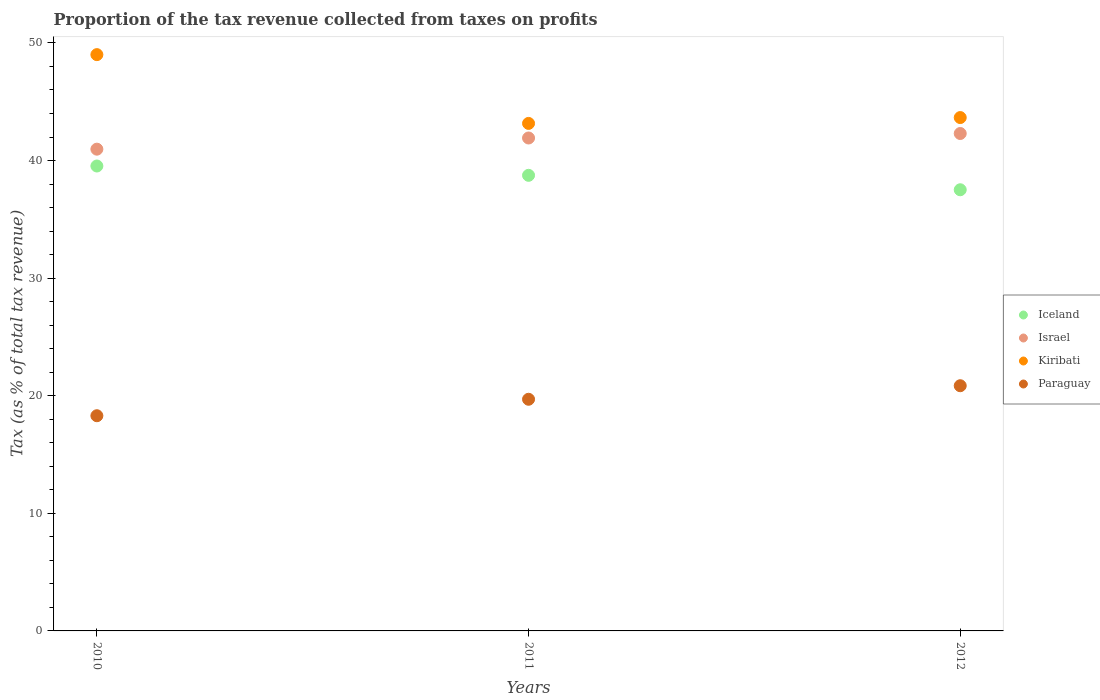How many different coloured dotlines are there?
Your answer should be compact. 4. Is the number of dotlines equal to the number of legend labels?
Give a very brief answer. Yes. What is the proportion of the tax revenue collected in Paraguay in 2011?
Keep it short and to the point. 19.7. Across all years, what is the maximum proportion of the tax revenue collected in Paraguay?
Provide a short and direct response. 20.85. Across all years, what is the minimum proportion of the tax revenue collected in Israel?
Keep it short and to the point. 40.97. In which year was the proportion of the tax revenue collected in Paraguay maximum?
Your response must be concise. 2012. In which year was the proportion of the tax revenue collected in Israel minimum?
Offer a very short reply. 2010. What is the total proportion of the tax revenue collected in Iceland in the graph?
Your response must be concise. 115.79. What is the difference between the proportion of the tax revenue collected in Paraguay in 2010 and that in 2011?
Keep it short and to the point. -1.4. What is the difference between the proportion of the tax revenue collected in Paraguay in 2011 and the proportion of the tax revenue collected in Israel in 2010?
Provide a succinct answer. -21.27. What is the average proportion of the tax revenue collected in Iceland per year?
Make the answer very short. 38.6. In the year 2010, what is the difference between the proportion of the tax revenue collected in Kiribati and proportion of the tax revenue collected in Paraguay?
Offer a terse response. 30.71. What is the ratio of the proportion of the tax revenue collected in Kiribati in 2010 to that in 2011?
Provide a short and direct response. 1.14. Is the proportion of the tax revenue collected in Israel in 2010 less than that in 2012?
Your response must be concise. Yes. Is the difference between the proportion of the tax revenue collected in Kiribati in 2010 and 2012 greater than the difference between the proportion of the tax revenue collected in Paraguay in 2010 and 2012?
Offer a terse response. Yes. What is the difference between the highest and the second highest proportion of the tax revenue collected in Paraguay?
Your answer should be very brief. 1.15. What is the difference between the highest and the lowest proportion of the tax revenue collected in Israel?
Ensure brevity in your answer.  1.33. Is the proportion of the tax revenue collected in Israel strictly greater than the proportion of the tax revenue collected in Kiribati over the years?
Provide a short and direct response. No. How many dotlines are there?
Offer a terse response. 4. How many years are there in the graph?
Give a very brief answer. 3. What is the difference between two consecutive major ticks on the Y-axis?
Offer a very short reply. 10. Are the values on the major ticks of Y-axis written in scientific E-notation?
Your answer should be very brief. No. Does the graph contain any zero values?
Your answer should be very brief. No. Where does the legend appear in the graph?
Offer a terse response. Center right. What is the title of the graph?
Ensure brevity in your answer.  Proportion of the tax revenue collected from taxes on profits. Does "Lao PDR" appear as one of the legend labels in the graph?
Give a very brief answer. No. What is the label or title of the Y-axis?
Provide a succinct answer. Tax (as % of total tax revenue). What is the Tax (as % of total tax revenue) of Iceland in 2010?
Ensure brevity in your answer.  39.53. What is the Tax (as % of total tax revenue) of Israel in 2010?
Offer a very short reply. 40.97. What is the Tax (as % of total tax revenue) in Kiribati in 2010?
Make the answer very short. 49. What is the Tax (as % of total tax revenue) in Paraguay in 2010?
Your answer should be compact. 18.3. What is the Tax (as % of total tax revenue) in Iceland in 2011?
Ensure brevity in your answer.  38.74. What is the Tax (as % of total tax revenue) of Israel in 2011?
Make the answer very short. 41.92. What is the Tax (as % of total tax revenue) of Kiribati in 2011?
Offer a very short reply. 43.16. What is the Tax (as % of total tax revenue) in Paraguay in 2011?
Provide a succinct answer. 19.7. What is the Tax (as % of total tax revenue) of Iceland in 2012?
Provide a short and direct response. 37.51. What is the Tax (as % of total tax revenue) of Israel in 2012?
Make the answer very short. 42.3. What is the Tax (as % of total tax revenue) of Kiribati in 2012?
Give a very brief answer. 43.65. What is the Tax (as % of total tax revenue) of Paraguay in 2012?
Your response must be concise. 20.85. Across all years, what is the maximum Tax (as % of total tax revenue) in Iceland?
Give a very brief answer. 39.53. Across all years, what is the maximum Tax (as % of total tax revenue) of Israel?
Make the answer very short. 42.3. Across all years, what is the maximum Tax (as % of total tax revenue) in Kiribati?
Ensure brevity in your answer.  49. Across all years, what is the maximum Tax (as % of total tax revenue) in Paraguay?
Offer a very short reply. 20.85. Across all years, what is the minimum Tax (as % of total tax revenue) in Iceland?
Your answer should be compact. 37.51. Across all years, what is the minimum Tax (as % of total tax revenue) of Israel?
Give a very brief answer. 40.97. Across all years, what is the minimum Tax (as % of total tax revenue) in Kiribati?
Ensure brevity in your answer.  43.16. Across all years, what is the minimum Tax (as % of total tax revenue) in Paraguay?
Ensure brevity in your answer.  18.3. What is the total Tax (as % of total tax revenue) in Iceland in the graph?
Your answer should be compact. 115.79. What is the total Tax (as % of total tax revenue) of Israel in the graph?
Your response must be concise. 125.18. What is the total Tax (as % of total tax revenue) of Kiribati in the graph?
Your response must be concise. 135.81. What is the total Tax (as % of total tax revenue) of Paraguay in the graph?
Keep it short and to the point. 58.85. What is the difference between the Tax (as % of total tax revenue) of Iceland in 2010 and that in 2011?
Provide a short and direct response. 0.79. What is the difference between the Tax (as % of total tax revenue) in Israel in 2010 and that in 2011?
Give a very brief answer. -0.95. What is the difference between the Tax (as % of total tax revenue) in Kiribati in 2010 and that in 2011?
Your answer should be very brief. 5.85. What is the difference between the Tax (as % of total tax revenue) in Paraguay in 2010 and that in 2011?
Keep it short and to the point. -1.4. What is the difference between the Tax (as % of total tax revenue) of Iceland in 2010 and that in 2012?
Offer a terse response. 2.02. What is the difference between the Tax (as % of total tax revenue) of Israel in 2010 and that in 2012?
Make the answer very short. -1.33. What is the difference between the Tax (as % of total tax revenue) of Kiribati in 2010 and that in 2012?
Provide a short and direct response. 5.35. What is the difference between the Tax (as % of total tax revenue) of Paraguay in 2010 and that in 2012?
Your answer should be very brief. -2.55. What is the difference between the Tax (as % of total tax revenue) in Iceland in 2011 and that in 2012?
Your answer should be compact. 1.23. What is the difference between the Tax (as % of total tax revenue) in Israel in 2011 and that in 2012?
Provide a short and direct response. -0.38. What is the difference between the Tax (as % of total tax revenue) of Kiribati in 2011 and that in 2012?
Your answer should be compact. -0.5. What is the difference between the Tax (as % of total tax revenue) in Paraguay in 2011 and that in 2012?
Offer a very short reply. -1.15. What is the difference between the Tax (as % of total tax revenue) in Iceland in 2010 and the Tax (as % of total tax revenue) in Israel in 2011?
Your response must be concise. -2.38. What is the difference between the Tax (as % of total tax revenue) of Iceland in 2010 and the Tax (as % of total tax revenue) of Kiribati in 2011?
Give a very brief answer. -3.62. What is the difference between the Tax (as % of total tax revenue) of Iceland in 2010 and the Tax (as % of total tax revenue) of Paraguay in 2011?
Offer a terse response. 19.84. What is the difference between the Tax (as % of total tax revenue) of Israel in 2010 and the Tax (as % of total tax revenue) of Kiribati in 2011?
Your answer should be compact. -2.19. What is the difference between the Tax (as % of total tax revenue) of Israel in 2010 and the Tax (as % of total tax revenue) of Paraguay in 2011?
Your response must be concise. 21.27. What is the difference between the Tax (as % of total tax revenue) in Kiribati in 2010 and the Tax (as % of total tax revenue) in Paraguay in 2011?
Your answer should be compact. 29.31. What is the difference between the Tax (as % of total tax revenue) of Iceland in 2010 and the Tax (as % of total tax revenue) of Israel in 2012?
Offer a very short reply. -2.76. What is the difference between the Tax (as % of total tax revenue) of Iceland in 2010 and the Tax (as % of total tax revenue) of Kiribati in 2012?
Keep it short and to the point. -4.12. What is the difference between the Tax (as % of total tax revenue) in Iceland in 2010 and the Tax (as % of total tax revenue) in Paraguay in 2012?
Offer a very short reply. 18.68. What is the difference between the Tax (as % of total tax revenue) of Israel in 2010 and the Tax (as % of total tax revenue) of Kiribati in 2012?
Your answer should be very brief. -2.69. What is the difference between the Tax (as % of total tax revenue) in Israel in 2010 and the Tax (as % of total tax revenue) in Paraguay in 2012?
Make the answer very short. 20.12. What is the difference between the Tax (as % of total tax revenue) in Kiribati in 2010 and the Tax (as % of total tax revenue) in Paraguay in 2012?
Make the answer very short. 28.15. What is the difference between the Tax (as % of total tax revenue) in Iceland in 2011 and the Tax (as % of total tax revenue) in Israel in 2012?
Give a very brief answer. -3.56. What is the difference between the Tax (as % of total tax revenue) of Iceland in 2011 and the Tax (as % of total tax revenue) of Kiribati in 2012?
Give a very brief answer. -4.91. What is the difference between the Tax (as % of total tax revenue) in Iceland in 2011 and the Tax (as % of total tax revenue) in Paraguay in 2012?
Provide a succinct answer. 17.89. What is the difference between the Tax (as % of total tax revenue) of Israel in 2011 and the Tax (as % of total tax revenue) of Kiribati in 2012?
Keep it short and to the point. -1.74. What is the difference between the Tax (as % of total tax revenue) in Israel in 2011 and the Tax (as % of total tax revenue) in Paraguay in 2012?
Provide a succinct answer. 21.07. What is the difference between the Tax (as % of total tax revenue) in Kiribati in 2011 and the Tax (as % of total tax revenue) in Paraguay in 2012?
Your answer should be compact. 22.31. What is the average Tax (as % of total tax revenue) of Iceland per year?
Provide a succinct answer. 38.6. What is the average Tax (as % of total tax revenue) of Israel per year?
Your answer should be compact. 41.73. What is the average Tax (as % of total tax revenue) of Kiribati per year?
Ensure brevity in your answer.  45.27. What is the average Tax (as % of total tax revenue) in Paraguay per year?
Ensure brevity in your answer.  19.62. In the year 2010, what is the difference between the Tax (as % of total tax revenue) of Iceland and Tax (as % of total tax revenue) of Israel?
Offer a terse response. -1.43. In the year 2010, what is the difference between the Tax (as % of total tax revenue) in Iceland and Tax (as % of total tax revenue) in Kiribati?
Your answer should be very brief. -9.47. In the year 2010, what is the difference between the Tax (as % of total tax revenue) in Iceland and Tax (as % of total tax revenue) in Paraguay?
Offer a terse response. 21.24. In the year 2010, what is the difference between the Tax (as % of total tax revenue) in Israel and Tax (as % of total tax revenue) in Kiribati?
Ensure brevity in your answer.  -8.04. In the year 2010, what is the difference between the Tax (as % of total tax revenue) of Israel and Tax (as % of total tax revenue) of Paraguay?
Keep it short and to the point. 22.67. In the year 2010, what is the difference between the Tax (as % of total tax revenue) in Kiribati and Tax (as % of total tax revenue) in Paraguay?
Provide a short and direct response. 30.71. In the year 2011, what is the difference between the Tax (as % of total tax revenue) in Iceland and Tax (as % of total tax revenue) in Israel?
Provide a short and direct response. -3.17. In the year 2011, what is the difference between the Tax (as % of total tax revenue) of Iceland and Tax (as % of total tax revenue) of Kiribati?
Ensure brevity in your answer.  -4.41. In the year 2011, what is the difference between the Tax (as % of total tax revenue) in Iceland and Tax (as % of total tax revenue) in Paraguay?
Your response must be concise. 19.04. In the year 2011, what is the difference between the Tax (as % of total tax revenue) of Israel and Tax (as % of total tax revenue) of Kiribati?
Offer a very short reply. -1.24. In the year 2011, what is the difference between the Tax (as % of total tax revenue) of Israel and Tax (as % of total tax revenue) of Paraguay?
Offer a terse response. 22.22. In the year 2011, what is the difference between the Tax (as % of total tax revenue) in Kiribati and Tax (as % of total tax revenue) in Paraguay?
Your answer should be compact. 23.46. In the year 2012, what is the difference between the Tax (as % of total tax revenue) of Iceland and Tax (as % of total tax revenue) of Israel?
Your answer should be very brief. -4.78. In the year 2012, what is the difference between the Tax (as % of total tax revenue) of Iceland and Tax (as % of total tax revenue) of Kiribati?
Offer a very short reply. -6.14. In the year 2012, what is the difference between the Tax (as % of total tax revenue) in Iceland and Tax (as % of total tax revenue) in Paraguay?
Your answer should be compact. 16.66. In the year 2012, what is the difference between the Tax (as % of total tax revenue) in Israel and Tax (as % of total tax revenue) in Kiribati?
Your answer should be very brief. -1.36. In the year 2012, what is the difference between the Tax (as % of total tax revenue) in Israel and Tax (as % of total tax revenue) in Paraguay?
Provide a succinct answer. 21.45. In the year 2012, what is the difference between the Tax (as % of total tax revenue) of Kiribati and Tax (as % of total tax revenue) of Paraguay?
Your response must be concise. 22.8. What is the ratio of the Tax (as % of total tax revenue) in Iceland in 2010 to that in 2011?
Your answer should be compact. 1.02. What is the ratio of the Tax (as % of total tax revenue) in Israel in 2010 to that in 2011?
Keep it short and to the point. 0.98. What is the ratio of the Tax (as % of total tax revenue) in Kiribati in 2010 to that in 2011?
Make the answer very short. 1.14. What is the ratio of the Tax (as % of total tax revenue) of Paraguay in 2010 to that in 2011?
Your answer should be compact. 0.93. What is the ratio of the Tax (as % of total tax revenue) of Iceland in 2010 to that in 2012?
Keep it short and to the point. 1.05. What is the ratio of the Tax (as % of total tax revenue) of Israel in 2010 to that in 2012?
Provide a short and direct response. 0.97. What is the ratio of the Tax (as % of total tax revenue) of Kiribati in 2010 to that in 2012?
Ensure brevity in your answer.  1.12. What is the ratio of the Tax (as % of total tax revenue) of Paraguay in 2010 to that in 2012?
Offer a terse response. 0.88. What is the ratio of the Tax (as % of total tax revenue) in Iceland in 2011 to that in 2012?
Provide a short and direct response. 1.03. What is the ratio of the Tax (as % of total tax revenue) in Paraguay in 2011 to that in 2012?
Make the answer very short. 0.94. What is the difference between the highest and the second highest Tax (as % of total tax revenue) of Iceland?
Give a very brief answer. 0.79. What is the difference between the highest and the second highest Tax (as % of total tax revenue) of Israel?
Make the answer very short. 0.38. What is the difference between the highest and the second highest Tax (as % of total tax revenue) of Kiribati?
Offer a very short reply. 5.35. What is the difference between the highest and the second highest Tax (as % of total tax revenue) in Paraguay?
Make the answer very short. 1.15. What is the difference between the highest and the lowest Tax (as % of total tax revenue) of Iceland?
Offer a terse response. 2.02. What is the difference between the highest and the lowest Tax (as % of total tax revenue) of Israel?
Keep it short and to the point. 1.33. What is the difference between the highest and the lowest Tax (as % of total tax revenue) in Kiribati?
Make the answer very short. 5.85. What is the difference between the highest and the lowest Tax (as % of total tax revenue) of Paraguay?
Your answer should be compact. 2.55. 